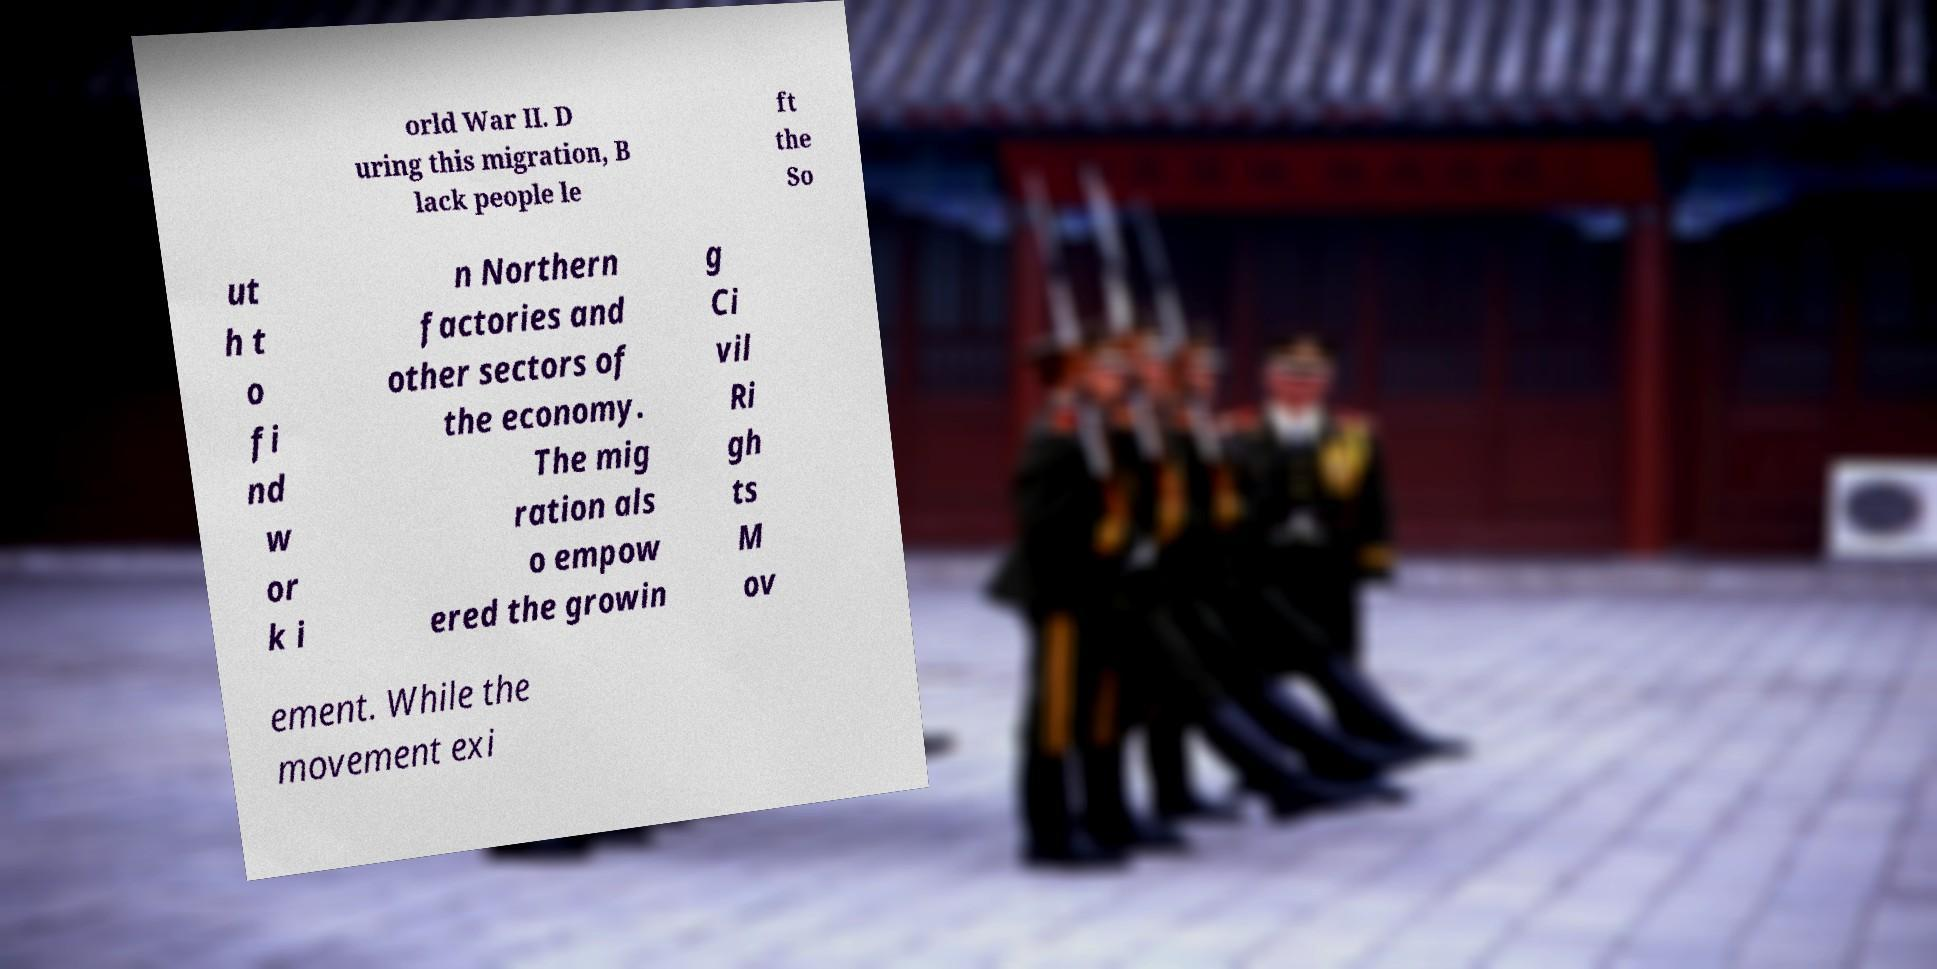Can you read and provide the text displayed in the image?This photo seems to have some interesting text. Can you extract and type it out for me? orld War II. D uring this migration, B lack people le ft the So ut h t o fi nd w or k i n Northern factories and other sectors of the economy. The mig ration als o empow ered the growin g Ci vil Ri gh ts M ov ement. While the movement exi 